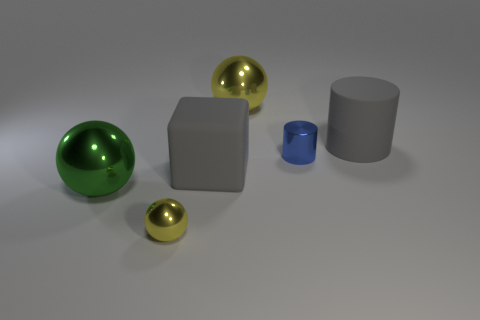Subtract all small yellow metal spheres. How many spheres are left? 2 Add 2 metal things. How many objects exist? 8 Subtract all gray cylinders. How many cylinders are left? 1 Subtract all cubes. How many objects are left? 5 Subtract 2 cylinders. How many cylinders are left? 0 Subtract all gray cubes. How many yellow spheres are left? 2 Add 3 large gray cylinders. How many large gray cylinders exist? 4 Subtract 1 green balls. How many objects are left? 5 Subtract all blue cylinders. Subtract all purple balls. How many cylinders are left? 1 Subtract all yellow metallic objects. Subtract all metal spheres. How many objects are left? 1 